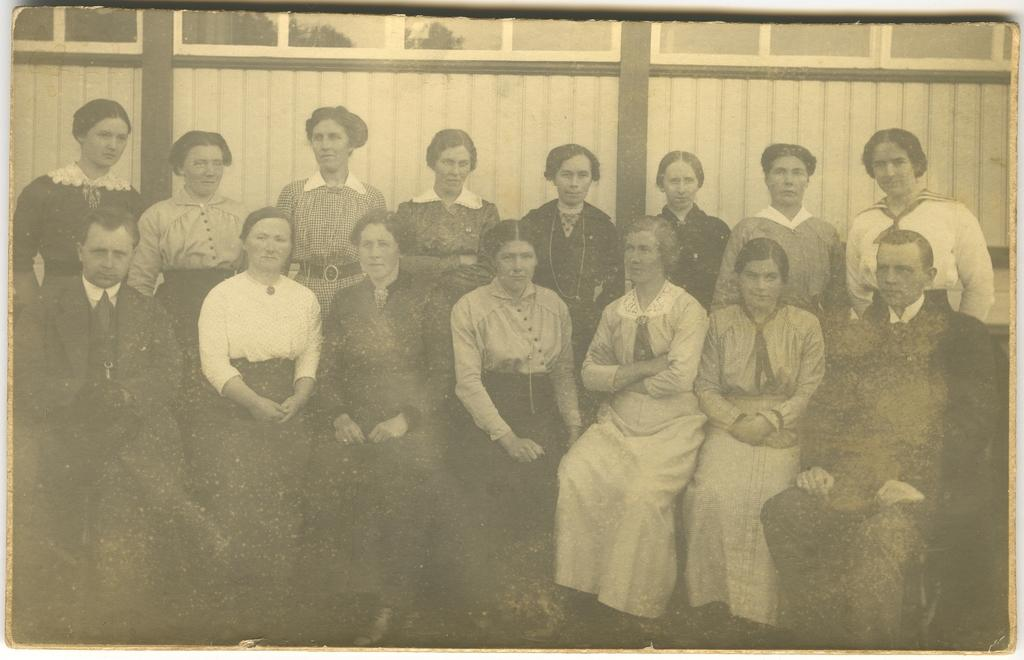What is the main subject of the image? There is a photo in the image. What can be seen in the photo? The photo contains a group of people. What are the people in the photo wearing? The people in the photo are wearing dresses. What is visible in the background of the photo? There is a building in the background of the photo. How is the photo described? The photo is described as old. What type of yam is being served at the event in the photo? There is no yam present in the image, nor is there any indication of an event taking place. --- Facts: 1. There is a car in the image. 2. The car is red. 3. The car has four wheels. 4. There is a road in the image. 5. The road is paved. Absurd Topics: parrot, ocean, dance Conversation: What is the main subject of the image? There is a car in the image. What color is the car? The car is red. How many wheels does the car have? The car has four wheels. What is visible in the background of the image? There is a road in the image. What type of road is visible in the image? The road is paved. Reasoning: Let's think step by step in order to produce the conversation. We start by identifying the main subject of the image, which is the car. Then, we describe the car's color and the number of wheels it has. Next, we mention the background of the image, which features a road. Finally, we include the description of the road as paved, which adds detail to the image. Absurd Question/Answer: Can you see a parrot flying over the car in the image? There is no parrot present in the image. --- Facts: 1. There is a person holding a book in the image. 2. The book is open. 3. The person is sitting on a chair. 4. There is a table in the image. 5. The table has a lamp on it. Absurd Topics: elephant, rain, guitar Conversation: What is the person in the image doing? The person is holding a book in the image. What is the state of the book? The book is open. Where is the person sitting? The person is sitting on a chair. What is visible on the table in the image? There is a lamp on the table in the image. Reasoning: Let's think step by step in order to produce the conversation. We start by identifying the main subject of the image, which is the person holding a book. Then, we describe the state of the book, which is open. Next, we mention the person's location 